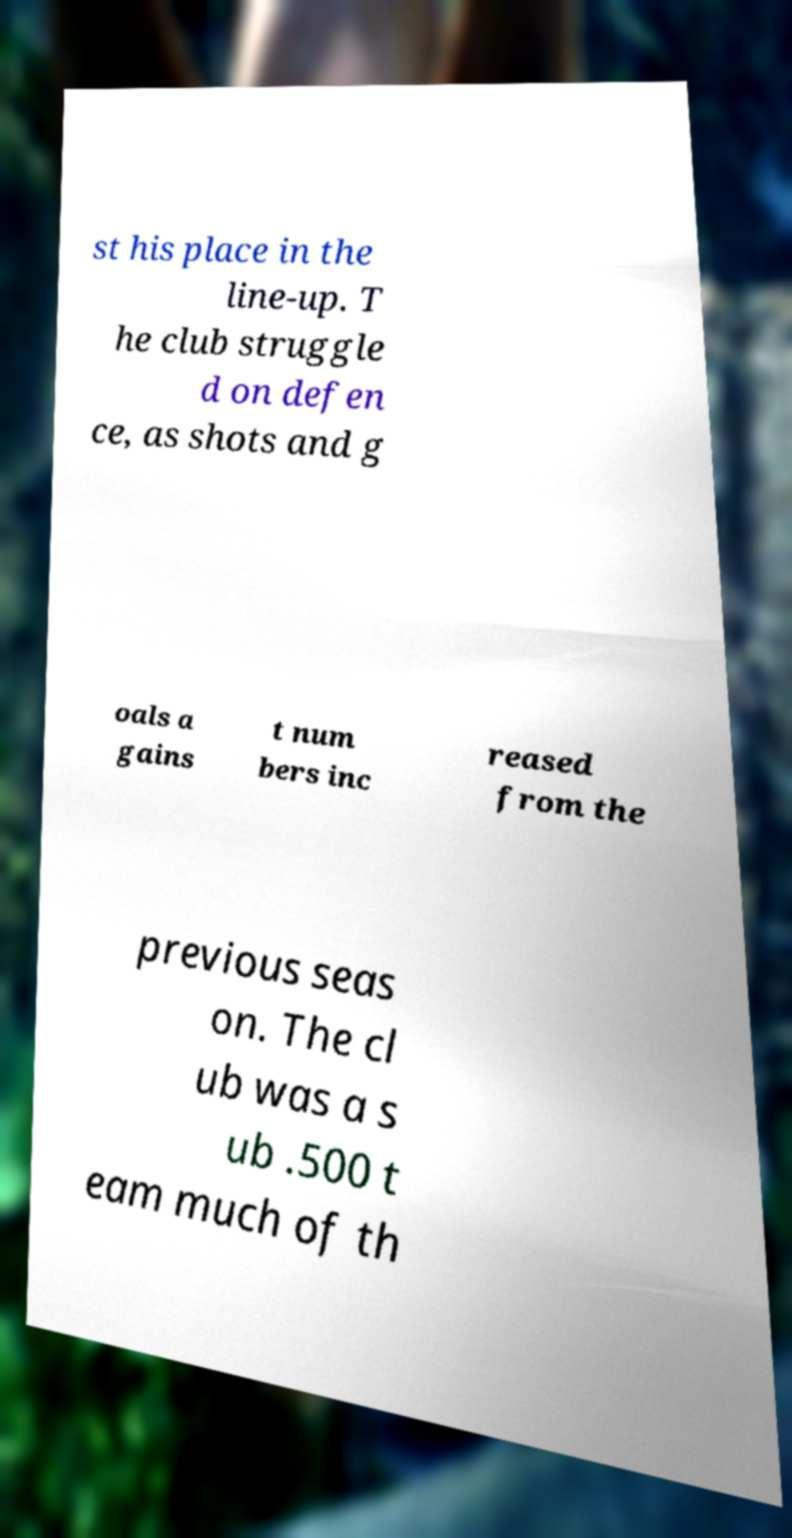What messages or text are displayed in this image? I need them in a readable, typed format. st his place in the line-up. T he club struggle d on defen ce, as shots and g oals a gains t num bers inc reased from the previous seas on. The cl ub was a s ub .500 t eam much of th 